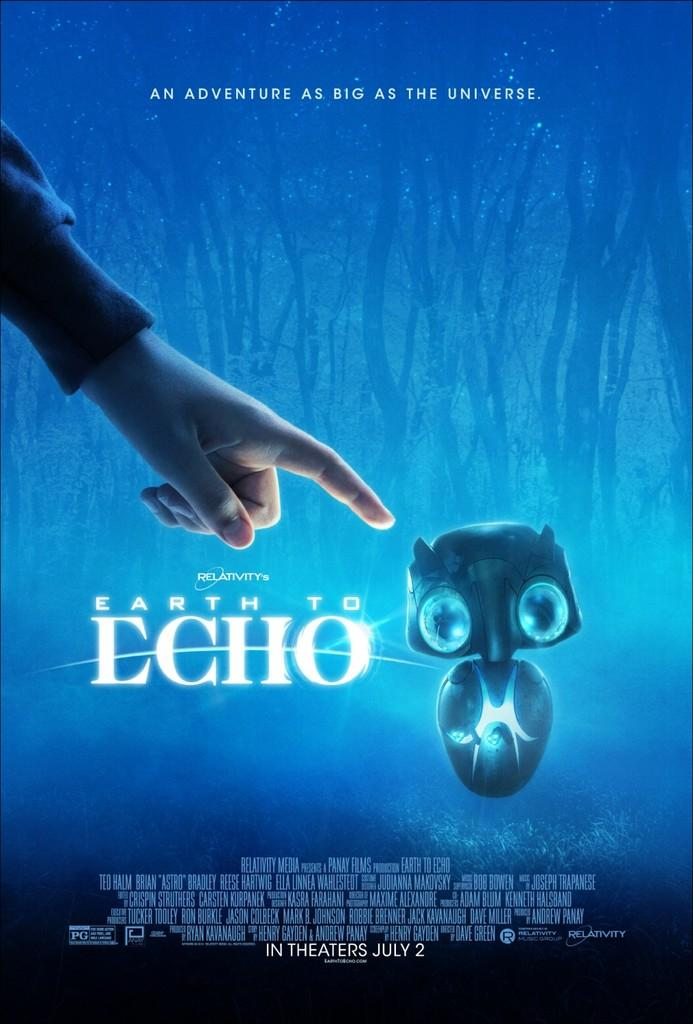What is depicted on the poster in the image? There is a poster of an animated cartoon in the image. What additional information can be found on the poster? The poster has text on it. What does the text on the poster say? The text says "an adventure as big as the earth." What type of health advice is given on the poster in the image? There is no health advice present on the poster in the image; it features a poster of an animated cartoon with text about an adventure. 